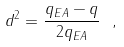<formula> <loc_0><loc_0><loc_500><loc_500>d ^ { 2 } = \frac { q _ { E A } - q } { 2 q _ { E A } } \ ,</formula> 